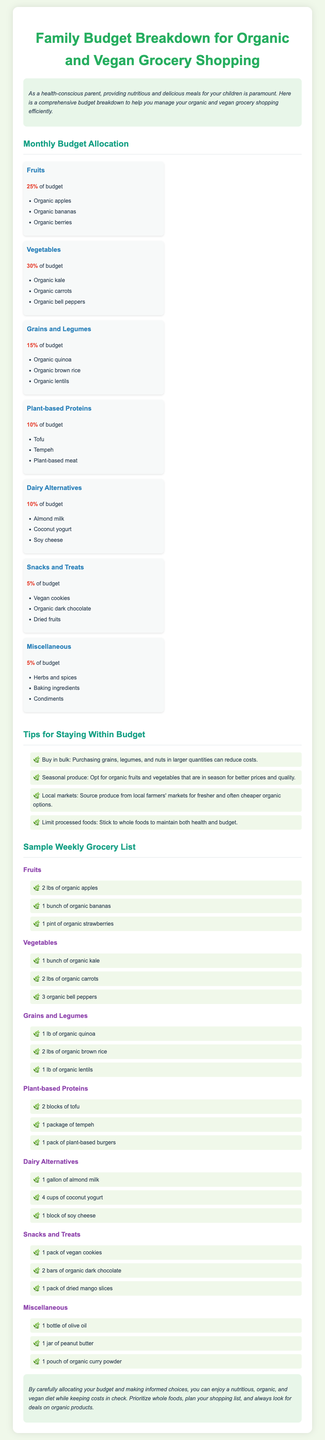What percentage of the budget is allocated to vegetables? The document states that 30% of the budget is allocated to vegetables.
Answer: 30% What items are included in the snacks and treats category? The snacks and treats category includes vegan cookies, organic dark chocolate, and dried fruits.
Answer: Vegan cookies, organic dark chocolate, dried fruits How much of the budget is dedicated to dairy alternatives? The document indicates that 10% of the budget is allocated to dairy alternatives.
Answer: 10% What is one tip provided for staying within budget? The document suggests buying in bulk as a way to reduce costs.
Answer: Buy in bulk What is the total percentage of the budget allocated to fruits and vegetables combined? The budget allocation for fruits is 25% and for vegetables is 30%, which adds up to 55%.
Answer: 55% Which plant-based protein is listed in the grocery list? The grocery list mentions tofu, tempeh, and plant-based burgers as plant-based proteins.
Answer: Tofu What is the main purpose of the document? The document aims to help health-conscious parents manage their organic and vegan grocery shopping budget efficiently.
Answer: Manage grocery budget How many items are in the grains and legumes section of the grocery list? The document lists three items under grains and legumes: quinoa, brown rice, and lentils.
Answer: Three items 